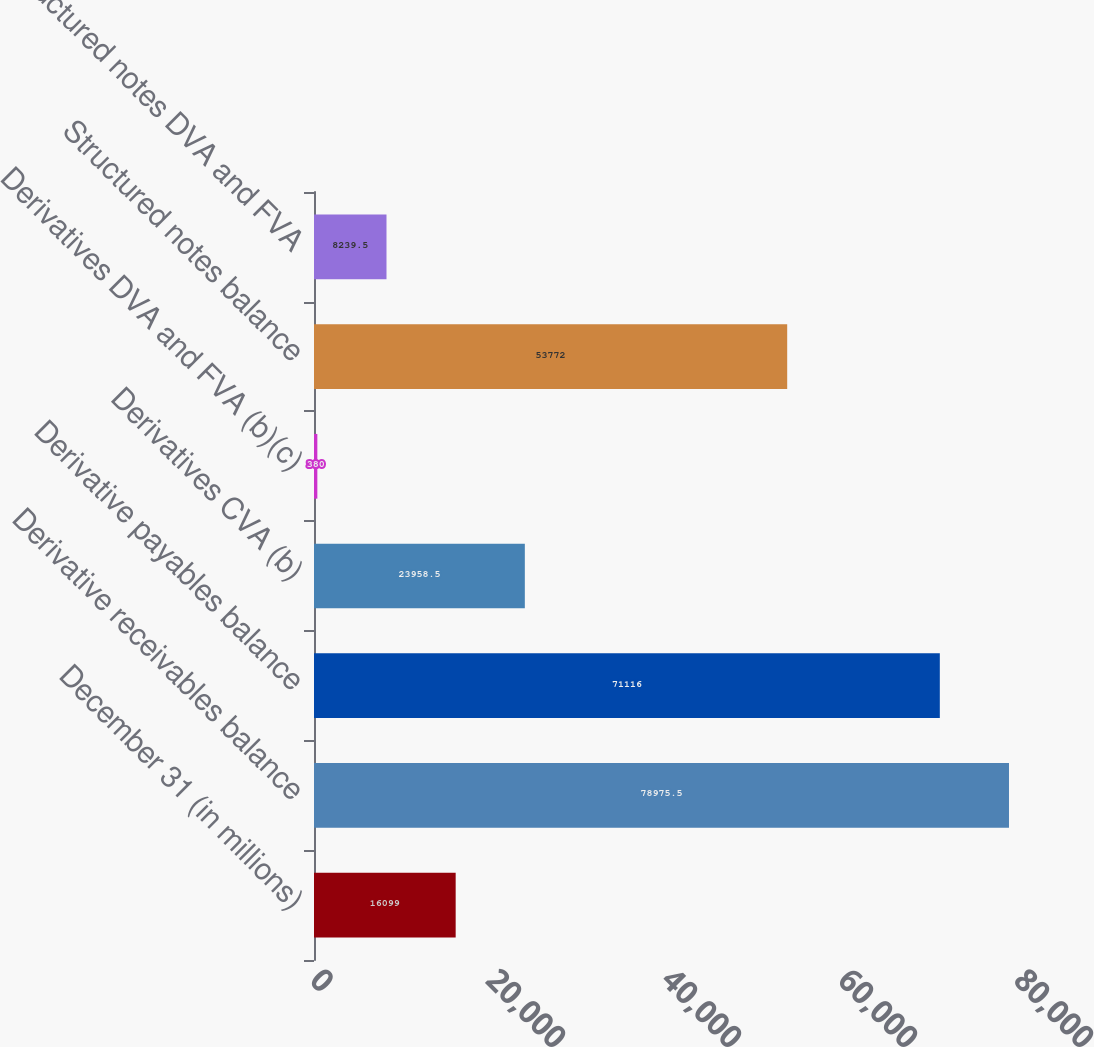Convert chart to OTSL. <chart><loc_0><loc_0><loc_500><loc_500><bar_chart><fcel>December 31 (in millions)<fcel>Derivative receivables balance<fcel>Derivative payables balance<fcel>Derivatives CVA (b)<fcel>Derivatives DVA and FVA (b)(c)<fcel>Structured notes balance<fcel>Structured notes DVA and FVA<nl><fcel>16099<fcel>78975.5<fcel>71116<fcel>23958.5<fcel>380<fcel>53772<fcel>8239.5<nl></chart> 